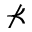Convert formula to latex. <formula><loc_0><loc_0><loc_500><loc_500>\nprec</formula> 